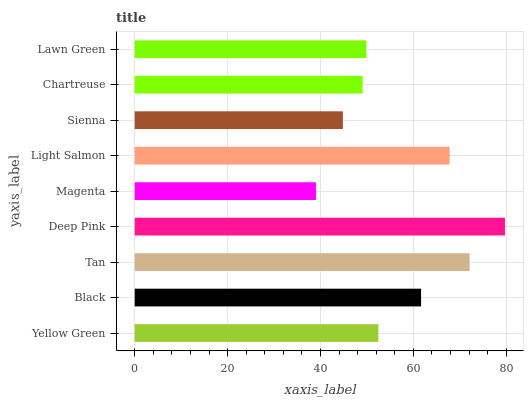Is Magenta the minimum?
Answer yes or no. Yes. Is Deep Pink the maximum?
Answer yes or no. Yes. Is Black the minimum?
Answer yes or no. No. Is Black the maximum?
Answer yes or no. No. Is Black greater than Yellow Green?
Answer yes or no. Yes. Is Yellow Green less than Black?
Answer yes or no. Yes. Is Yellow Green greater than Black?
Answer yes or no. No. Is Black less than Yellow Green?
Answer yes or no. No. Is Yellow Green the high median?
Answer yes or no. Yes. Is Yellow Green the low median?
Answer yes or no. Yes. Is Black the high median?
Answer yes or no. No. Is Deep Pink the low median?
Answer yes or no. No. 